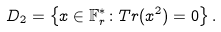Convert formula to latex. <formula><loc_0><loc_0><loc_500><loc_500>D _ { 2 } = \left \{ x \in \mathbb { F } _ { r } ^ { * } \colon T r ( x ^ { 2 } ) = 0 \right \} .</formula> 